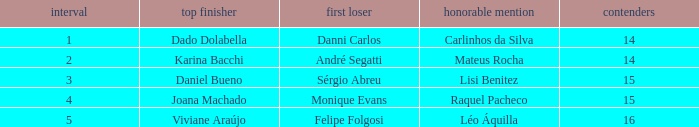Who finished in third place when the winner was Karina Bacchi?  Mateus Rocha. Parse the table in full. {'header': ['interval', 'top finisher', 'first loser', 'honorable mention', 'contenders'], 'rows': [['1', 'Dado Dolabella', 'Danni Carlos', 'Carlinhos da Silva', '14'], ['2', 'Karina Bacchi', 'André Segatti', 'Mateus Rocha', '14'], ['3', 'Daniel Bueno', 'Sérgio Abreu', 'Lisi Benitez', '15'], ['4', 'Joana Machado', 'Monique Evans', 'Raquel Pacheco', '15'], ['5', 'Viviane Araújo', 'Felipe Folgosi', 'Léo Áquilla', '16']]} 